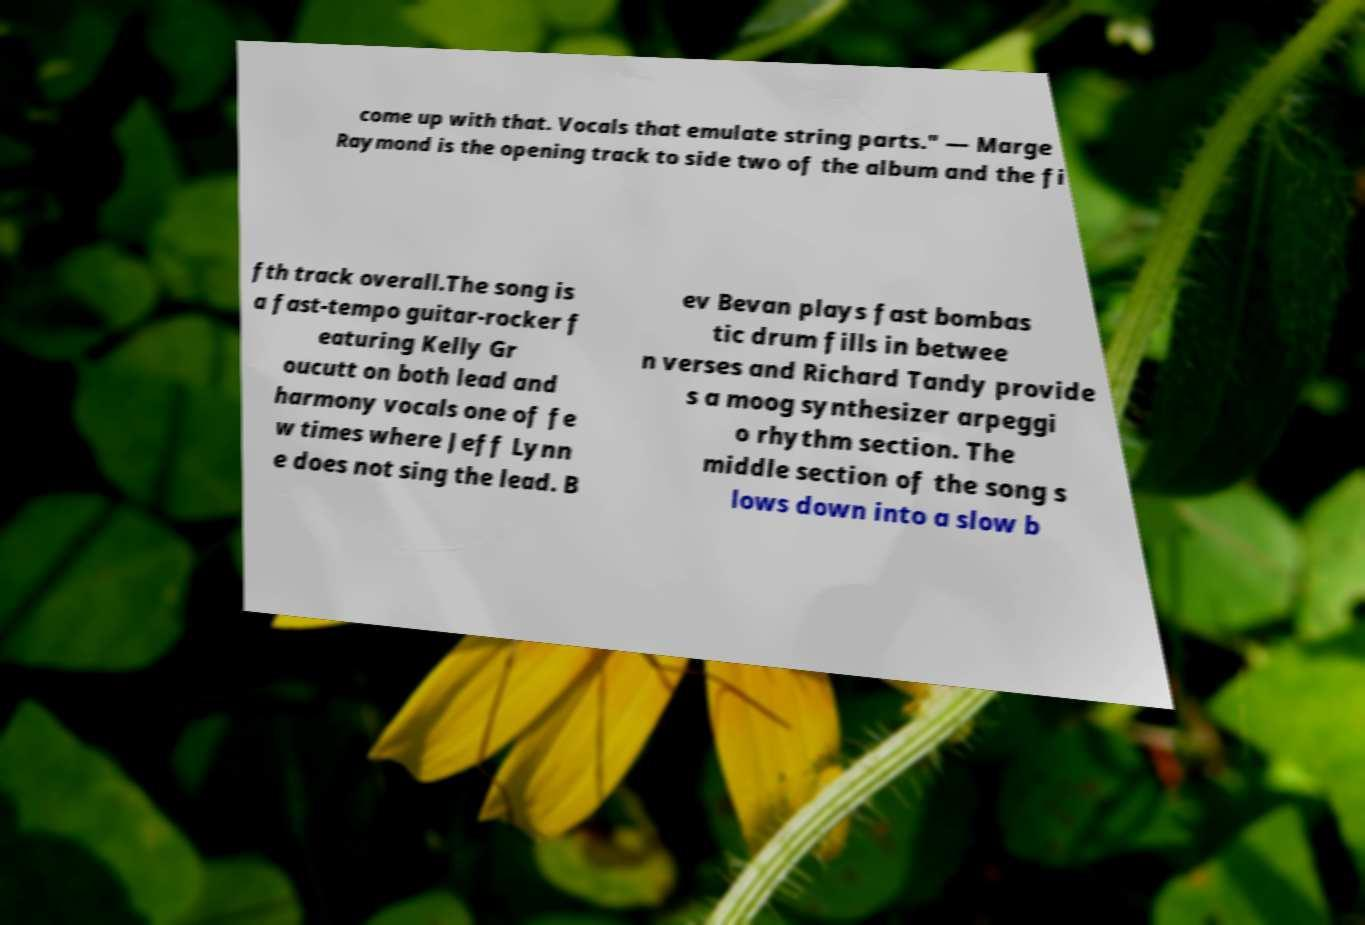There's text embedded in this image that I need extracted. Can you transcribe it verbatim? come up with that. Vocals that emulate string parts." — Marge Raymond is the opening track to side two of the album and the fi fth track overall.The song is a fast-tempo guitar-rocker f eaturing Kelly Gr oucutt on both lead and harmony vocals one of fe w times where Jeff Lynn e does not sing the lead. B ev Bevan plays fast bombas tic drum fills in betwee n verses and Richard Tandy provide s a moog synthesizer arpeggi o rhythm section. The middle section of the song s lows down into a slow b 